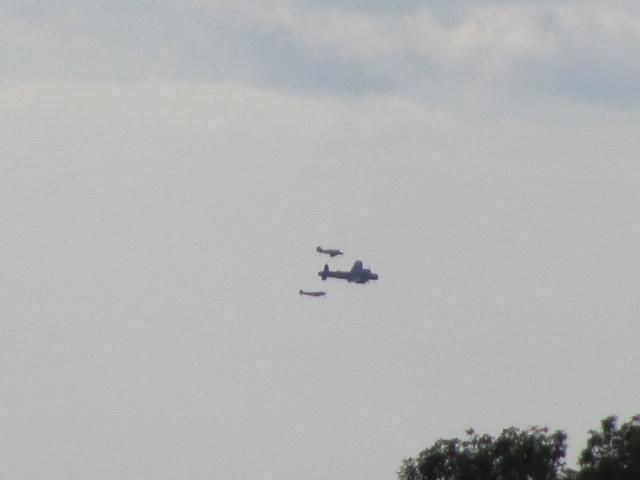How many planes are in the sky?
Give a very brief answer. 3. How many planes?
Give a very brief answer. 3. 